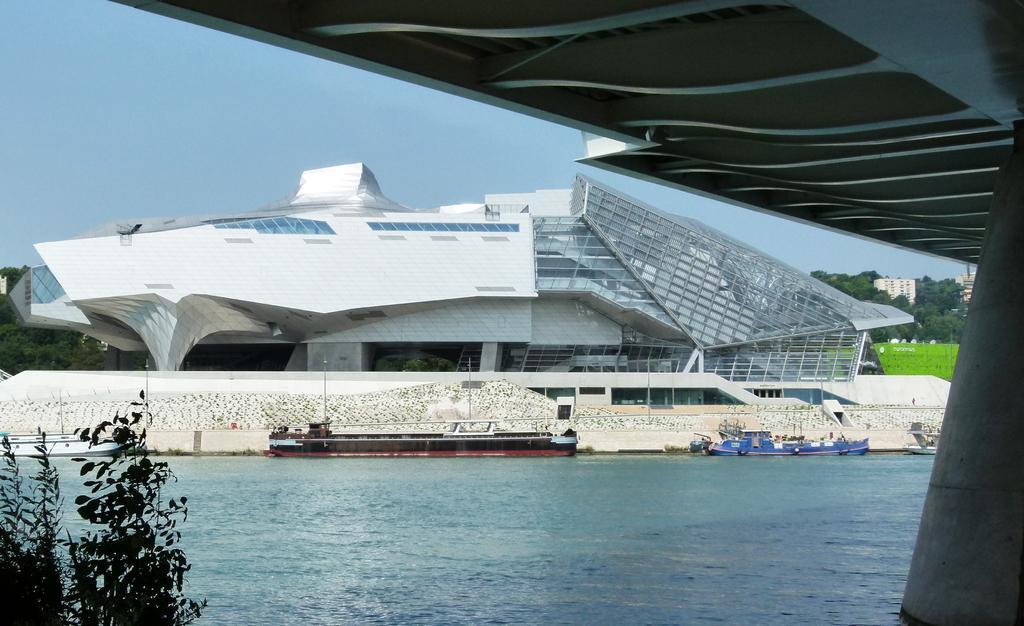Can you describe this image briefly? At the bottom of the image I can see the water. It is looking like a sea and there are two boats. In the background there are some buildings and trees. On the right side, I can see a pillar in the water. It is looking like a bridge. On the left bottom of the image there is a plant. On the top of the image I can see the sky. 